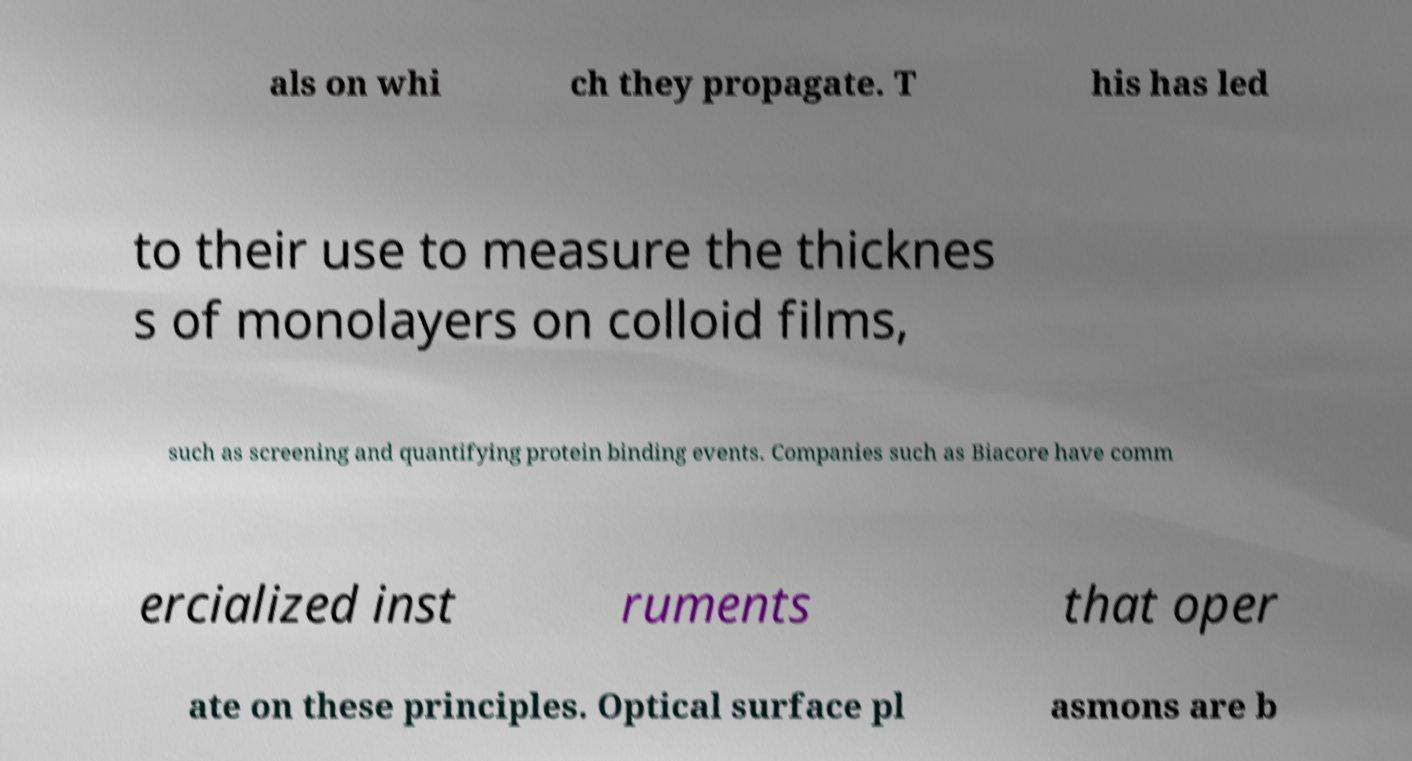For documentation purposes, I need the text within this image transcribed. Could you provide that? als on whi ch they propagate. T his has led to their use to measure the thicknes s of monolayers on colloid films, such as screening and quantifying protein binding events. Companies such as Biacore have comm ercialized inst ruments that oper ate on these principles. Optical surface pl asmons are b 